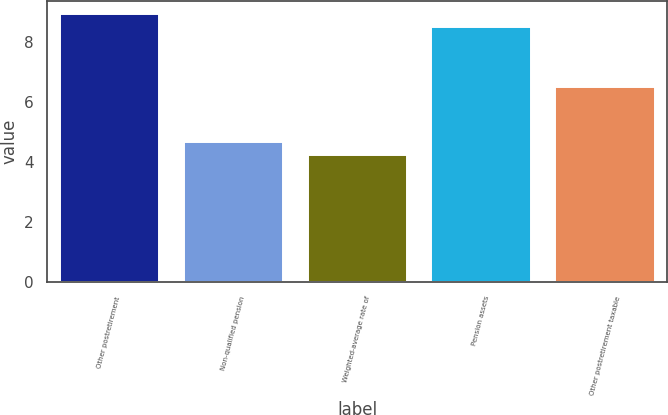Convert chart to OTSL. <chart><loc_0><loc_0><loc_500><loc_500><bar_chart><fcel>Other postretirement<fcel>Non-qualified pension<fcel>Weighted-average rate of<fcel>Pension assets<fcel>Other postretirement taxable<nl><fcel>8.93<fcel>4.66<fcel>4.23<fcel>8.5<fcel>6.5<nl></chart> 